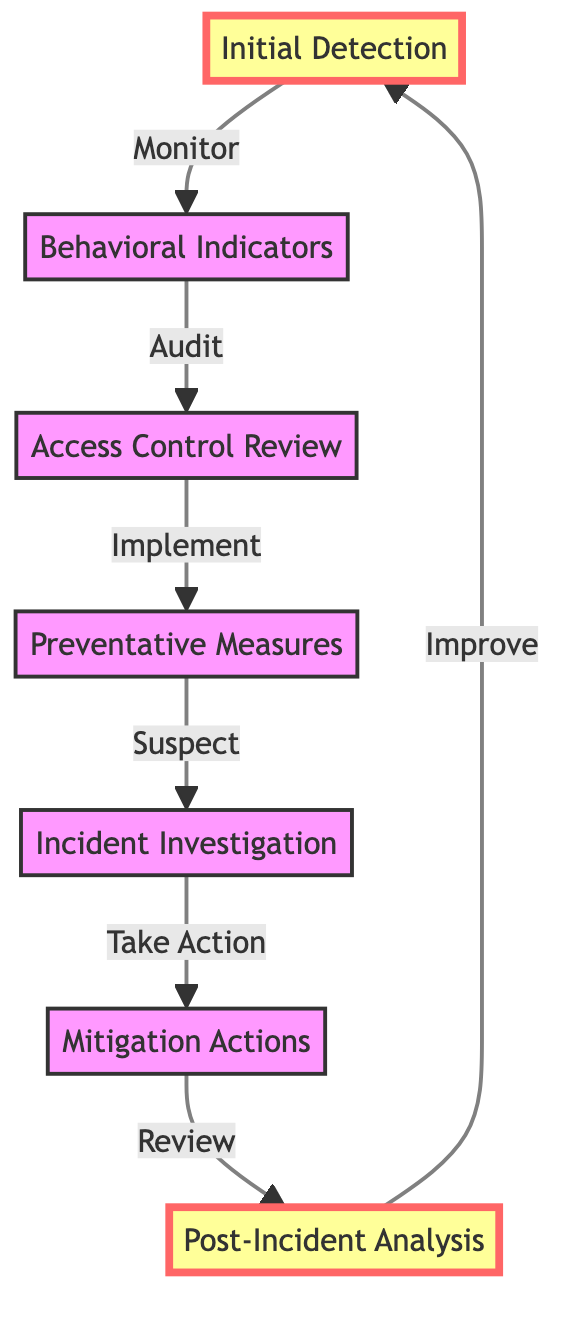What is the first stage in the flow chart? The first stage is labeled "Initial Detection" which is clearly indicated as the starting point of the flow chart.
Answer: Initial Detection How many stages are in the diagram? Counting the elements represented in the flow chart, there are seven distinct stages or nodes.
Answer: 7 What follows "Behavioral Indicators"? From the flow chart, "Behavioral Indicators" leads to "Access Control Review", as indicated by the directional arrow connecting these two nodes.
Answer: Access Control Review Which stage involves collaboration between departments? The stage "Incident Investigation" involves collaboration between HR, IT, and legal departments, as explicitly stated in the description of that node.
Answer: Incident Investigation What is the action taken after "Mitigation Actions"? Following "Mitigation Actions", the flow chart leads to "Post-Incident Analysis", which is the next stage.
Answer: Post-Incident Analysis What happens after "Post-Incident Analysis"? The flow chart indicates that after "Post-Incident Analysis", the process loops back to "Initial Detection", suggesting a continuous cycle of monitoring and improvement.
Answer: Initial Detection What is a preventative measure mentioned in the chart? The flow chart describes "Implementing security awareness training" as one of the preventative measures, specifically listed under the "Preventative Measures" stage.
Answer: Implementing security awareness training Which two stages are emphasized in the flow chart? The flow chart uses bold formatting to emphasize "Initial Detection" and "Post-Incident Analysis", indicating their significance within the process.
Answer: Initial Detection and Post-Incident Analysis What type of connection exists between "Preventative Measures" and "Incident Investigation"? The relationship is directional, indicating that "Preventative Measures" leads to or results in "Incident Investigation" when a suspect is identified, as shown by the arrow between these nodes.
Answer: Suspect 